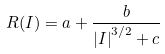<formula> <loc_0><loc_0><loc_500><loc_500>R ( I ) = a + \frac { b } { \left | I \right | ^ { 3 / 2 } + c }</formula> 